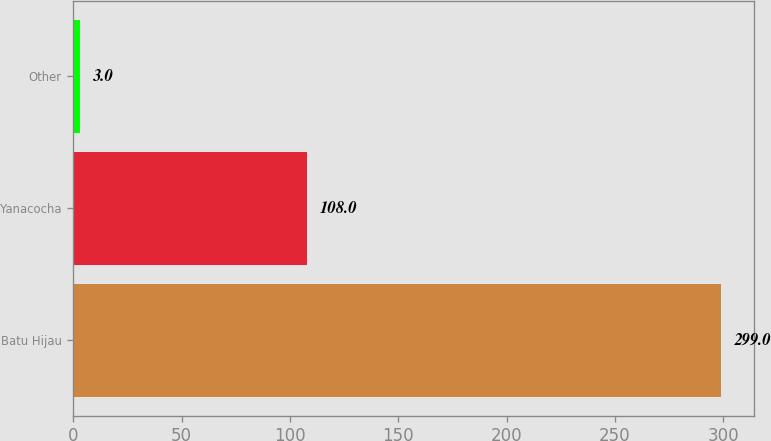Convert chart. <chart><loc_0><loc_0><loc_500><loc_500><bar_chart><fcel>Batu Hijau<fcel>Yanacocha<fcel>Other<nl><fcel>299<fcel>108<fcel>3<nl></chart> 